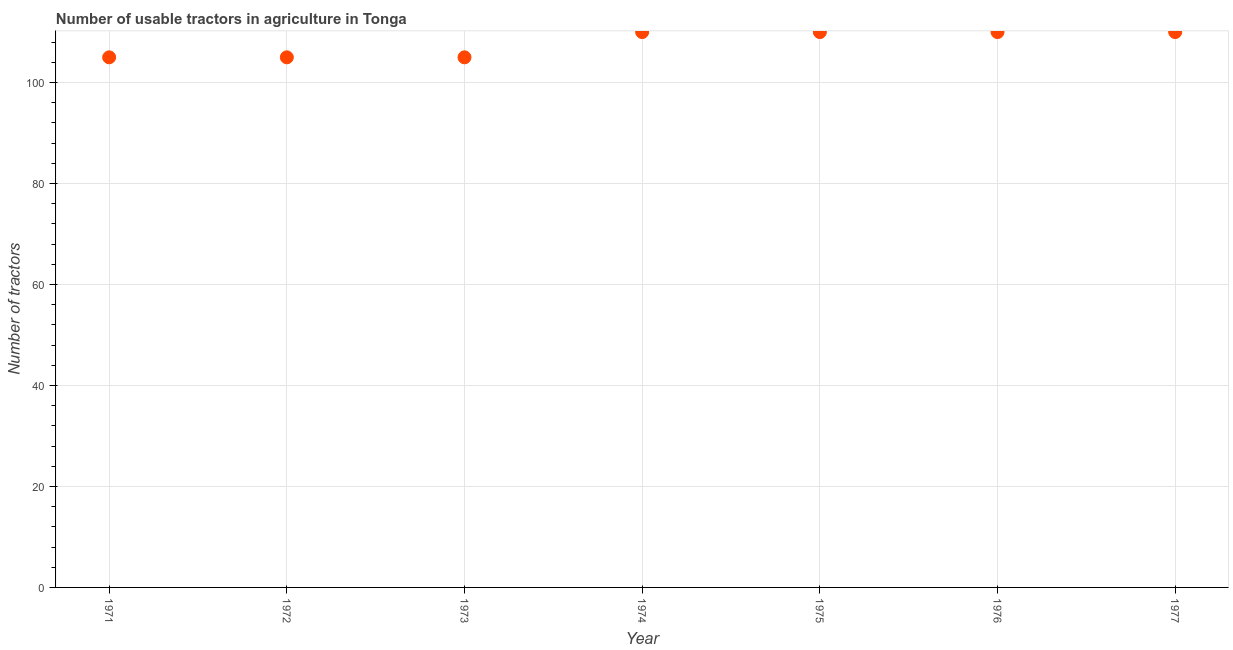What is the number of tractors in 1972?
Your response must be concise. 105. Across all years, what is the maximum number of tractors?
Give a very brief answer. 110. Across all years, what is the minimum number of tractors?
Provide a succinct answer. 105. In which year was the number of tractors maximum?
Ensure brevity in your answer.  1974. In which year was the number of tractors minimum?
Give a very brief answer. 1971. What is the sum of the number of tractors?
Make the answer very short. 755. What is the difference between the number of tractors in 1973 and 1976?
Give a very brief answer. -5. What is the average number of tractors per year?
Make the answer very short. 107.86. What is the median number of tractors?
Offer a very short reply. 110. What is the ratio of the number of tractors in 1971 to that in 1977?
Your answer should be compact. 0.95. Is the number of tractors in 1974 less than that in 1976?
Make the answer very short. No. Is the difference between the number of tractors in 1971 and 1972 greater than the difference between any two years?
Provide a succinct answer. No. What is the difference between the highest and the second highest number of tractors?
Your answer should be compact. 0. Is the sum of the number of tractors in 1971 and 1972 greater than the maximum number of tractors across all years?
Keep it short and to the point. Yes. What is the difference between the highest and the lowest number of tractors?
Ensure brevity in your answer.  5. In how many years, is the number of tractors greater than the average number of tractors taken over all years?
Make the answer very short. 4. Does the number of tractors monotonically increase over the years?
Your answer should be very brief. No. How many dotlines are there?
Your response must be concise. 1. How many years are there in the graph?
Your response must be concise. 7. What is the difference between two consecutive major ticks on the Y-axis?
Your answer should be very brief. 20. Does the graph contain any zero values?
Offer a very short reply. No. What is the title of the graph?
Ensure brevity in your answer.  Number of usable tractors in agriculture in Tonga. What is the label or title of the X-axis?
Your answer should be very brief. Year. What is the label or title of the Y-axis?
Ensure brevity in your answer.  Number of tractors. What is the Number of tractors in 1971?
Make the answer very short. 105. What is the Number of tractors in 1972?
Offer a terse response. 105. What is the Number of tractors in 1973?
Offer a very short reply. 105. What is the Number of tractors in 1974?
Your answer should be very brief. 110. What is the Number of tractors in 1975?
Offer a very short reply. 110. What is the Number of tractors in 1976?
Your answer should be compact. 110. What is the Number of tractors in 1977?
Provide a short and direct response. 110. What is the difference between the Number of tractors in 1971 and 1973?
Your answer should be compact. 0. What is the difference between the Number of tractors in 1971 and 1975?
Your answer should be very brief. -5. What is the difference between the Number of tractors in 1971 and 1976?
Keep it short and to the point. -5. What is the difference between the Number of tractors in 1971 and 1977?
Your answer should be very brief. -5. What is the difference between the Number of tractors in 1972 and 1975?
Offer a terse response. -5. What is the difference between the Number of tractors in 1972 and 1977?
Ensure brevity in your answer.  -5. What is the difference between the Number of tractors in 1973 and 1977?
Ensure brevity in your answer.  -5. What is the difference between the Number of tractors in 1974 and 1977?
Provide a short and direct response. 0. What is the difference between the Number of tractors in 1976 and 1977?
Keep it short and to the point. 0. What is the ratio of the Number of tractors in 1971 to that in 1974?
Provide a short and direct response. 0.95. What is the ratio of the Number of tractors in 1971 to that in 1975?
Your response must be concise. 0.95. What is the ratio of the Number of tractors in 1971 to that in 1976?
Keep it short and to the point. 0.95. What is the ratio of the Number of tractors in 1971 to that in 1977?
Ensure brevity in your answer.  0.95. What is the ratio of the Number of tractors in 1972 to that in 1974?
Give a very brief answer. 0.95. What is the ratio of the Number of tractors in 1972 to that in 1975?
Keep it short and to the point. 0.95. What is the ratio of the Number of tractors in 1972 to that in 1976?
Offer a very short reply. 0.95. What is the ratio of the Number of tractors in 1972 to that in 1977?
Your answer should be very brief. 0.95. What is the ratio of the Number of tractors in 1973 to that in 1974?
Offer a very short reply. 0.95. What is the ratio of the Number of tractors in 1973 to that in 1975?
Ensure brevity in your answer.  0.95. What is the ratio of the Number of tractors in 1973 to that in 1976?
Provide a short and direct response. 0.95. What is the ratio of the Number of tractors in 1973 to that in 1977?
Make the answer very short. 0.95. What is the ratio of the Number of tractors in 1974 to that in 1976?
Offer a very short reply. 1. 